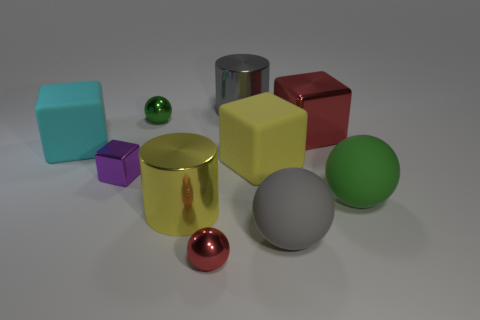There is a red object that is the same size as the purple metal object; what is its shape?
Provide a short and direct response. Sphere. How many things are big things on the right side of the small metallic block or large brown cylinders?
Give a very brief answer. 6. What is the size of the yellow thing right of the large gray metal cylinder?
Your answer should be compact. Large. Is there a sphere that has the same size as the purple thing?
Ensure brevity in your answer.  Yes. There is a gray object right of the gray shiny object; does it have the same size as the large red metal thing?
Offer a terse response. Yes. The red metallic ball is what size?
Your answer should be compact. Small. There is a sphere that is left of the small metal thing in front of the big gray rubber ball to the right of the big yellow shiny cylinder; what is its color?
Your response must be concise. Green. Does the small thing that is in front of the large yellow metal object have the same color as the tiny shiny block?
Your response must be concise. No. What number of objects are both left of the gray metal thing and in front of the green rubber object?
Ensure brevity in your answer.  2. The other shiny thing that is the same shape as the tiny green metal thing is what size?
Keep it short and to the point. Small. 